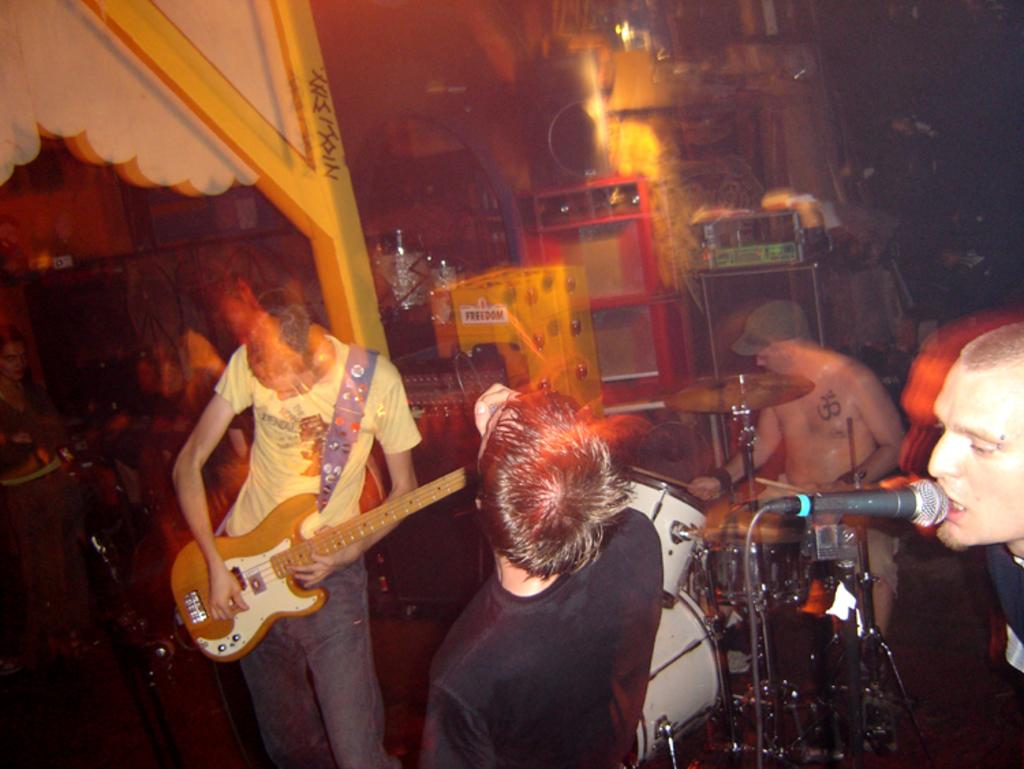What is the main activity of the group of people in the image? The group of people are playing music. Can you describe the person on the right side of the image? The person on the right side is singing and using a microphone. How many people are involved in the music-related activity in the image? There is a group of people playing music, but the exact number is not specified. What type of rock can be seen in the image? There is no rock present in the image; it features a group of people playing music. Can you describe the zephyr that is blowing through the microphone in the image? There is no mention of a zephyr or any wind-related phenomenon in the image. 